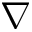<formula> <loc_0><loc_0><loc_500><loc_500>\nabla</formula> 